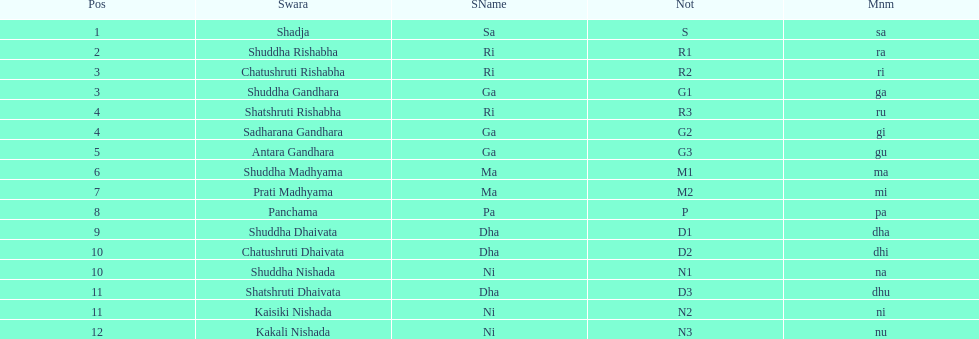What is the name of the swara that holds the first position? Shadja. 